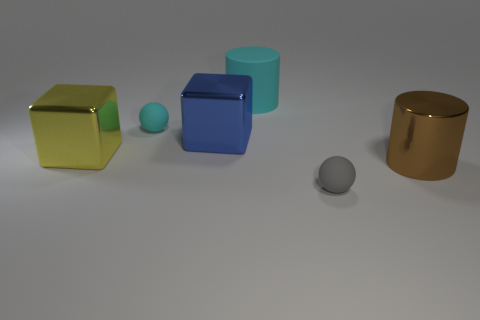Subtract all cubes. How many objects are left? 4 Subtract 2 cylinders. How many cylinders are left? 0 Subtract all yellow spheres. Subtract all gray cylinders. How many spheres are left? 2 Subtract all green spheres. How many cyan cylinders are left? 1 Subtract all small balls. Subtract all blue metal cubes. How many objects are left? 3 Add 3 blue metallic objects. How many blue metallic objects are left? 4 Add 3 big blue things. How many big blue things exist? 4 Add 1 large yellow things. How many objects exist? 7 Subtract all gray balls. How many balls are left? 1 Subtract 1 cyan balls. How many objects are left? 5 